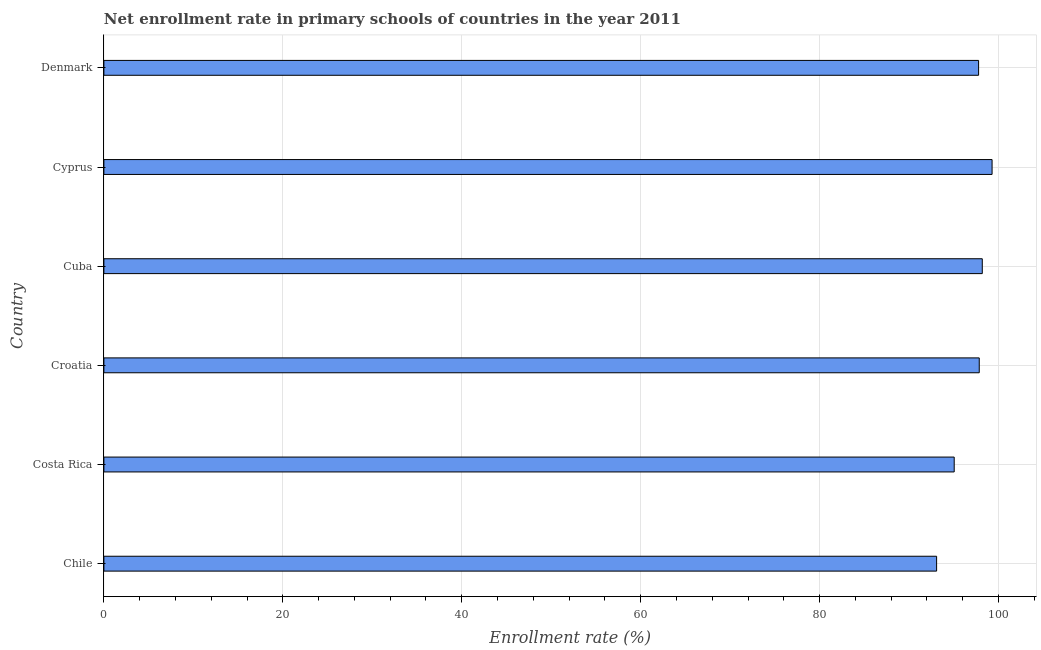Does the graph contain any zero values?
Your answer should be very brief. No. What is the title of the graph?
Offer a terse response. Net enrollment rate in primary schools of countries in the year 2011. What is the label or title of the X-axis?
Give a very brief answer. Enrollment rate (%). What is the net enrollment rate in primary schools in Costa Rica?
Ensure brevity in your answer.  95.05. Across all countries, what is the maximum net enrollment rate in primary schools?
Your answer should be very brief. 99.28. Across all countries, what is the minimum net enrollment rate in primary schools?
Give a very brief answer. 93.08. In which country was the net enrollment rate in primary schools maximum?
Your response must be concise. Cyprus. In which country was the net enrollment rate in primary schools minimum?
Ensure brevity in your answer.  Chile. What is the sum of the net enrollment rate in primary schools?
Make the answer very short. 581.21. What is the difference between the net enrollment rate in primary schools in Costa Rica and Denmark?
Make the answer very short. -2.73. What is the average net enrollment rate in primary schools per country?
Your answer should be very brief. 96.87. What is the median net enrollment rate in primary schools?
Keep it short and to the point. 97.81. In how many countries, is the net enrollment rate in primary schools greater than 4 %?
Ensure brevity in your answer.  6. What is the ratio of the net enrollment rate in primary schools in Costa Rica to that in Denmark?
Your response must be concise. 0.97. Is the difference between the net enrollment rate in primary schools in Cyprus and Denmark greater than the difference between any two countries?
Offer a terse response. No. What is the difference between the highest and the second highest net enrollment rate in primary schools?
Ensure brevity in your answer.  1.09. Is the sum of the net enrollment rate in primary schools in Costa Rica and Cyprus greater than the maximum net enrollment rate in primary schools across all countries?
Ensure brevity in your answer.  Yes. How many bars are there?
Provide a short and direct response. 6. How many countries are there in the graph?
Keep it short and to the point. 6. Are the values on the major ticks of X-axis written in scientific E-notation?
Keep it short and to the point. No. What is the Enrollment rate (%) of Chile?
Your response must be concise. 93.08. What is the Enrollment rate (%) in Costa Rica?
Offer a terse response. 95.05. What is the Enrollment rate (%) in Croatia?
Your answer should be compact. 97.85. What is the Enrollment rate (%) of Cuba?
Offer a terse response. 98.18. What is the Enrollment rate (%) of Cyprus?
Make the answer very short. 99.28. What is the Enrollment rate (%) in Denmark?
Your response must be concise. 97.77. What is the difference between the Enrollment rate (%) in Chile and Costa Rica?
Provide a short and direct response. -1.97. What is the difference between the Enrollment rate (%) in Chile and Croatia?
Give a very brief answer. -4.77. What is the difference between the Enrollment rate (%) in Chile and Cuba?
Offer a very short reply. -5.11. What is the difference between the Enrollment rate (%) in Chile and Cyprus?
Provide a succinct answer. -6.2. What is the difference between the Enrollment rate (%) in Chile and Denmark?
Keep it short and to the point. -4.69. What is the difference between the Enrollment rate (%) in Costa Rica and Croatia?
Make the answer very short. -2.8. What is the difference between the Enrollment rate (%) in Costa Rica and Cuba?
Offer a very short reply. -3.14. What is the difference between the Enrollment rate (%) in Costa Rica and Cyprus?
Ensure brevity in your answer.  -4.23. What is the difference between the Enrollment rate (%) in Costa Rica and Denmark?
Ensure brevity in your answer.  -2.73. What is the difference between the Enrollment rate (%) in Croatia and Cuba?
Ensure brevity in your answer.  -0.34. What is the difference between the Enrollment rate (%) in Croatia and Cyprus?
Offer a terse response. -1.43. What is the difference between the Enrollment rate (%) in Croatia and Denmark?
Give a very brief answer. 0.07. What is the difference between the Enrollment rate (%) in Cuba and Cyprus?
Ensure brevity in your answer.  -1.1. What is the difference between the Enrollment rate (%) in Cuba and Denmark?
Offer a very short reply. 0.41. What is the difference between the Enrollment rate (%) in Cyprus and Denmark?
Your answer should be very brief. 1.51. What is the ratio of the Enrollment rate (%) in Chile to that in Croatia?
Provide a short and direct response. 0.95. What is the ratio of the Enrollment rate (%) in Chile to that in Cuba?
Ensure brevity in your answer.  0.95. What is the ratio of the Enrollment rate (%) in Chile to that in Cyprus?
Offer a terse response. 0.94. What is the ratio of the Enrollment rate (%) in Chile to that in Denmark?
Your response must be concise. 0.95. What is the ratio of the Enrollment rate (%) in Costa Rica to that in Croatia?
Keep it short and to the point. 0.97. What is the ratio of the Enrollment rate (%) in Croatia to that in Cyprus?
Your answer should be very brief. 0.99. What is the ratio of the Enrollment rate (%) in Croatia to that in Denmark?
Your answer should be very brief. 1. What is the ratio of the Enrollment rate (%) in Cuba to that in Denmark?
Make the answer very short. 1. 